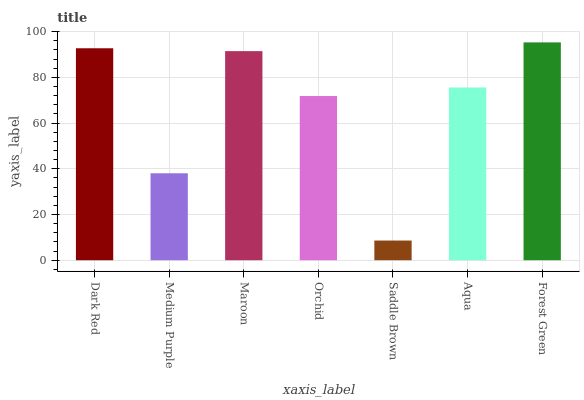Is Saddle Brown the minimum?
Answer yes or no. Yes. Is Forest Green the maximum?
Answer yes or no. Yes. Is Medium Purple the minimum?
Answer yes or no. No. Is Medium Purple the maximum?
Answer yes or no. No. Is Dark Red greater than Medium Purple?
Answer yes or no. Yes. Is Medium Purple less than Dark Red?
Answer yes or no. Yes. Is Medium Purple greater than Dark Red?
Answer yes or no. No. Is Dark Red less than Medium Purple?
Answer yes or no. No. Is Aqua the high median?
Answer yes or no. Yes. Is Aqua the low median?
Answer yes or no. Yes. Is Forest Green the high median?
Answer yes or no. No. Is Orchid the low median?
Answer yes or no. No. 